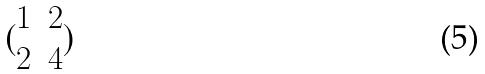Convert formula to latex. <formula><loc_0><loc_0><loc_500><loc_500>( \begin{matrix} 1 & 2 \\ 2 & 4 \end{matrix} )</formula> 